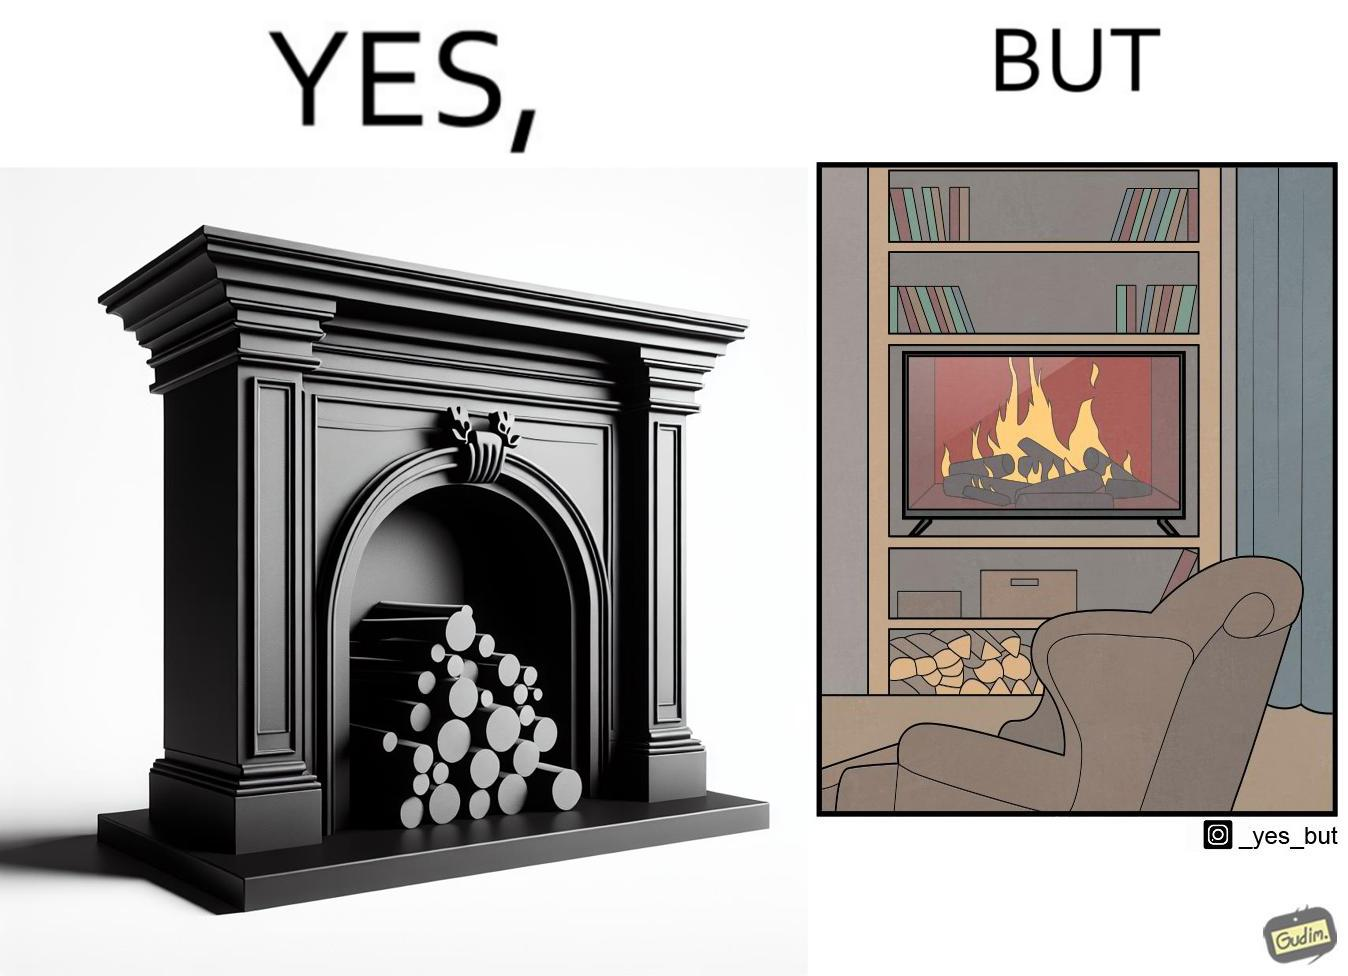Provide a description of this image. The images are funny since they show how even though real fireplaces exist, people choose to be lazy and watch fireplaces on television because they dont want the inconveniences of cleaning up, etc. afterwards 